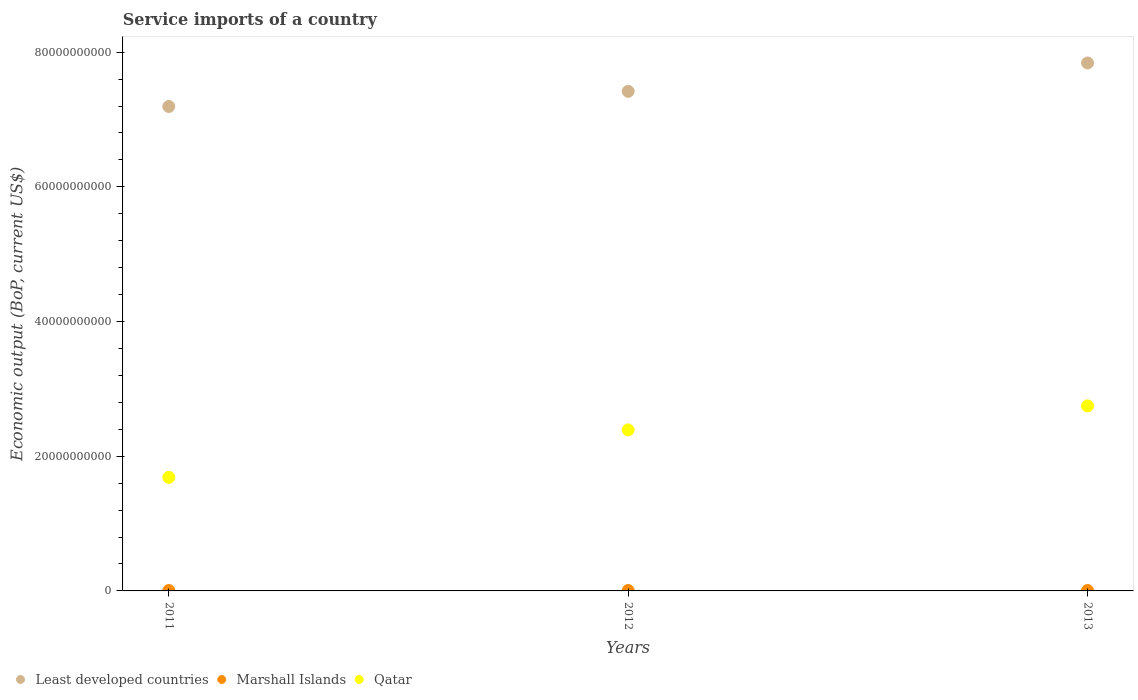Is the number of dotlines equal to the number of legend labels?
Give a very brief answer. Yes. What is the service imports in Least developed countries in 2011?
Provide a short and direct response. 7.19e+1. Across all years, what is the maximum service imports in Least developed countries?
Ensure brevity in your answer.  7.84e+1. Across all years, what is the minimum service imports in Marshall Islands?
Provide a succinct answer. 5.75e+07. What is the total service imports in Least developed countries in the graph?
Your answer should be very brief. 2.25e+11. What is the difference between the service imports in Marshall Islands in 2011 and that in 2012?
Keep it short and to the point. -2.94e+06. What is the difference between the service imports in Qatar in 2011 and the service imports in Least developed countries in 2012?
Provide a short and direct response. -5.73e+1. What is the average service imports in Marshall Islands per year?
Provide a succinct answer. 6.13e+07. In the year 2012, what is the difference between the service imports in Least developed countries and service imports in Qatar?
Ensure brevity in your answer.  5.03e+1. In how many years, is the service imports in Qatar greater than 12000000000 US$?
Give a very brief answer. 3. What is the ratio of the service imports in Marshall Islands in 2011 to that in 2012?
Give a very brief answer. 0.95. Is the service imports in Least developed countries in 2012 less than that in 2013?
Make the answer very short. Yes. What is the difference between the highest and the second highest service imports in Qatar?
Your response must be concise. 3.57e+09. What is the difference between the highest and the lowest service imports in Qatar?
Your answer should be compact. 1.06e+1. Does the service imports in Least developed countries monotonically increase over the years?
Provide a short and direct response. Yes. Is the service imports in Least developed countries strictly less than the service imports in Qatar over the years?
Offer a very short reply. No. How many dotlines are there?
Keep it short and to the point. 3. Does the graph contain grids?
Ensure brevity in your answer.  No. What is the title of the graph?
Your response must be concise. Service imports of a country. Does "Somalia" appear as one of the legend labels in the graph?
Provide a succinct answer. No. What is the label or title of the Y-axis?
Offer a terse response. Economic output (BoP, current US$). What is the Economic output (BoP, current US$) in Least developed countries in 2011?
Provide a short and direct response. 7.19e+1. What is the Economic output (BoP, current US$) in Marshall Islands in 2011?
Give a very brief answer. 5.75e+07. What is the Economic output (BoP, current US$) in Qatar in 2011?
Offer a very short reply. 1.69e+1. What is the Economic output (BoP, current US$) in Least developed countries in 2012?
Your answer should be compact. 7.42e+1. What is the Economic output (BoP, current US$) in Marshall Islands in 2012?
Your answer should be very brief. 6.04e+07. What is the Economic output (BoP, current US$) in Qatar in 2012?
Offer a very short reply. 2.39e+1. What is the Economic output (BoP, current US$) in Least developed countries in 2013?
Ensure brevity in your answer.  7.84e+1. What is the Economic output (BoP, current US$) of Marshall Islands in 2013?
Provide a succinct answer. 6.59e+07. What is the Economic output (BoP, current US$) in Qatar in 2013?
Ensure brevity in your answer.  2.75e+1. Across all years, what is the maximum Economic output (BoP, current US$) of Least developed countries?
Give a very brief answer. 7.84e+1. Across all years, what is the maximum Economic output (BoP, current US$) in Marshall Islands?
Your response must be concise. 6.59e+07. Across all years, what is the maximum Economic output (BoP, current US$) of Qatar?
Make the answer very short. 2.75e+1. Across all years, what is the minimum Economic output (BoP, current US$) in Least developed countries?
Your response must be concise. 7.19e+1. Across all years, what is the minimum Economic output (BoP, current US$) of Marshall Islands?
Make the answer very short. 5.75e+07. Across all years, what is the minimum Economic output (BoP, current US$) in Qatar?
Ensure brevity in your answer.  1.69e+1. What is the total Economic output (BoP, current US$) of Least developed countries in the graph?
Ensure brevity in your answer.  2.25e+11. What is the total Economic output (BoP, current US$) in Marshall Islands in the graph?
Keep it short and to the point. 1.84e+08. What is the total Economic output (BoP, current US$) of Qatar in the graph?
Provide a short and direct response. 6.83e+1. What is the difference between the Economic output (BoP, current US$) of Least developed countries in 2011 and that in 2012?
Make the answer very short. -2.25e+09. What is the difference between the Economic output (BoP, current US$) in Marshall Islands in 2011 and that in 2012?
Give a very brief answer. -2.94e+06. What is the difference between the Economic output (BoP, current US$) in Qatar in 2011 and that in 2012?
Make the answer very short. -7.04e+09. What is the difference between the Economic output (BoP, current US$) in Least developed countries in 2011 and that in 2013?
Give a very brief answer. -6.46e+09. What is the difference between the Economic output (BoP, current US$) of Marshall Islands in 2011 and that in 2013?
Your answer should be compact. -8.46e+06. What is the difference between the Economic output (BoP, current US$) in Qatar in 2011 and that in 2013?
Offer a terse response. -1.06e+1. What is the difference between the Economic output (BoP, current US$) of Least developed countries in 2012 and that in 2013?
Provide a short and direct response. -4.21e+09. What is the difference between the Economic output (BoP, current US$) in Marshall Islands in 2012 and that in 2013?
Offer a very short reply. -5.53e+06. What is the difference between the Economic output (BoP, current US$) of Qatar in 2012 and that in 2013?
Provide a short and direct response. -3.57e+09. What is the difference between the Economic output (BoP, current US$) of Least developed countries in 2011 and the Economic output (BoP, current US$) of Marshall Islands in 2012?
Your response must be concise. 7.19e+1. What is the difference between the Economic output (BoP, current US$) in Least developed countries in 2011 and the Economic output (BoP, current US$) in Qatar in 2012?
Keep it short and to the point. 4.80e+1. What is the difference between the Economic output (BoP, current US$) of Marshall Islands in 2011 and the Economic output (BoP, current US$) of Qatar in 2012?
Offer a very short reply. -2.38e+1. What is the difference between the Economic output (BoP, current US$) of Least developed countries in 2011 and the Economic output (BoP, current US$) of Marshall Islands in 2013?
Give a very brief answer. 7.19e+1. What is the difference between the Economic output (BoP, current US$) of Least developed countries in 2011 and the Economic output (BoP, current US$) of Qatar in 2013?
Make the answer very short. 4.45e+1. What is the difference between the Economic output (BoP, current US$) in Marshall Islands in 2011 and the Economic output (BoP, current US$) in Qatar in 2013?
Your answer should be very brief. -2.74e+1. What is the difference between the Economic output (BoP, current US$) of Least developed countries in 2012 and the Economic output (BoP, current US$) of Marshall Islands in 2013?
Your answer should be compact. 7.41e+1. What is the difference between the Economic output (BoP, current US$) in Least developed countries in 2012 and the Economic output (BoP, current US$) in Qatar in 2013?
Ensure brevity in your answer.  4.67e+1. What is the difference between the Economic output (BoP, current US$) of Marshall Islands in 2012 and the Economic output (BoP, current US$) of Qatar in 2013?
Your answer should be compact. -2.74e+1. What is the average Economic output (BoP, current US$) in Least developed countries per year?
Ensure brevity in your answer.  7.48e+1. What is the average Economic output (BoP, current US$) in Marshall Islands per year?
Provide a short and direct response. 6.13e+07. What is the average Economic output (BoP, current US$) in Qatar per year?
Offer a very short reply. 2.28e+1. In the year 2011, what is the difference between the Economic output (BoP, current US$) in Least developed countries and Economic output (BoP, current US$) in Marshall Islands?
Ensure brevity in your answer.  7.19e+1. In the year 2011, what is the difference between the Economic output (BoP, current US$) of Least developed countries and Economic output (BoP, current US$) of Qatar?
Your response must be concise. 5.51e+1. In the year 2011, what is the difference between the Economic output (BoP, current US$) in Marshall Islands and Economic output (BoP, current US$) in Qatar?
Offer a very short reply. -1.68e+1. In the year 2012, what is the difference between the Economic output (BoP, current US$) in Least developed countries and Economic output (BoP, current US$) in Marshall Islands?
Keep it short and to the point. 7.41e+1. In the year 2012, what is the difference between the Economic output (BoP, current US$) in Least developed countries and Economic output (BoP, current US$) in Qatar?
Ensure brevity in your answer.  5.03e+1. In the year 2012, what is the difference between the Economic output (BoP, current US$) in Marshall Islands and Economic output (BoP, current US$) in Qatar?
Your answer should be compact. -2.38e+1. In the year 2013, what is the difference between the Economic output (BoP, current US$) in Least developed countries and Economic output (BoP, current US$) in Marshall Islands?
Offer a terse response. 7.83e+1. In the year 2013, what is the difference between the Economic output (BoP, current US$) in Least developed countries and Economic output (BoP, current US$) in Qatar?
Provide a succinct answer. 5.09e+1. In the year 2013, what is the difference between the Economic output (BoP, current US$) in Marshall Islands and Economic output (BoP, current US$) in Qatar?
Your answer should be very brief. -2.74e+1. What is the ratio of the Economic output (BoP, current US$) of Least developed countries in 2011 to that in 2012?
Offer a terse response. 0.97. What is the ratio of the Economic output (BoP, current US$) of Marshall Islands in 2011 to that in 2012?
Keep it short and to the point. 0.95. What is the ratio of the Economic output (BoP, current US$) of Qatar in 2011 to that in 2012?
Your response must be concise. 0.71. What is the ratio of the Economic output (BoP, current US$) of Least developed countries in 2011 to that in 2013?
Your response must be concise. 0.92. What is the ratio of the Economic output (BoP, current US$) of Marshall Islands in 2011 to that in 2013?
Your answer should be very brief. 0.87. What is the ratio of the Economic output (BoP, current US$) of Qatar in 2011 to that in 2013?
Ensure brevity in your answer.  0.61. What is the ratio of the Economic output (BoP, current US$) of Least developed countries in 2012 to that in 2013?
Offer a very short reply. 0.95. What is the ratio of the Economic output (BoP, current US$) in Marshall Islands in 2012 to that in 2013?
Provide a succinct answer. 0.92. What is the ratio of the Economic output (BoP, current US$) of Qatar in 2012 to that in 2013?
Ensure brevity in your answer.  0.87. What is the difference between the highest and the second highest Economic output (BoP, current US$) in Least developed countries?
Your answer should be very brief. 4.21e+09. What is the difference between the highest and the second highest Economic output (BoP, current US$) in Marshall Islands?
Provide a succinct answer. 5.53e+06. What is the difference between the highest and the second highest Economic output (BoP, current US$) of Qatar?
Keep it short and to the point. 3.57e+09. What is the difference between the highest and the lowest Economic output (BoP, current US$) of Least developed countries?
Provide a succinct answer. 6.46e+09. What is the difference between the highest and the lowest Economic output (BoP, current US$) in Marshall Islands?
Your answer should be compact. 8.46e+06. What is the difference between the highest and the lowest Economic output (BoP, current US$) of Qatar?
Provide a succinct answer. 1.06e+1. 